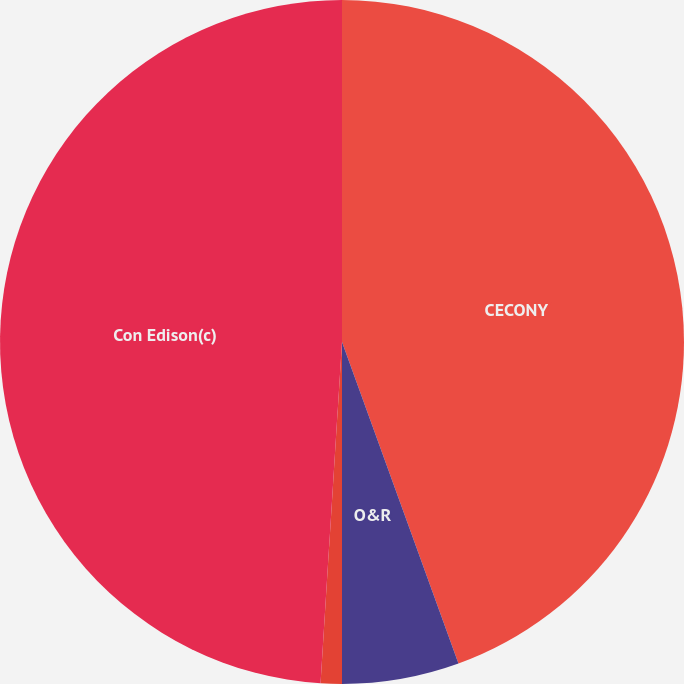<chart> <loc_0><loc_0><loc_500><loc_500><pie_chart><fcel>CECONY<fcel>O&R<fcel>Competitive energy<fcel>Con Edison(c)<nl><fcel>44.47%<fcel>5.53%<fcel>1.0%<fcel>49.0%<nl></chart> 